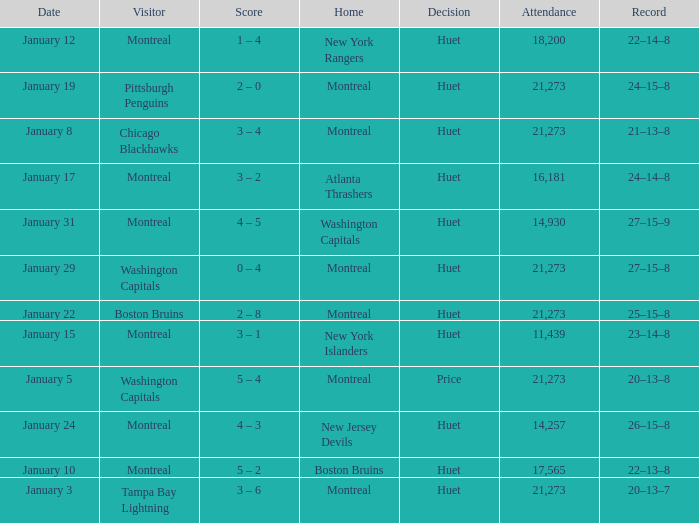What was the date of the game that had a score of 3 – 1? January 15. 